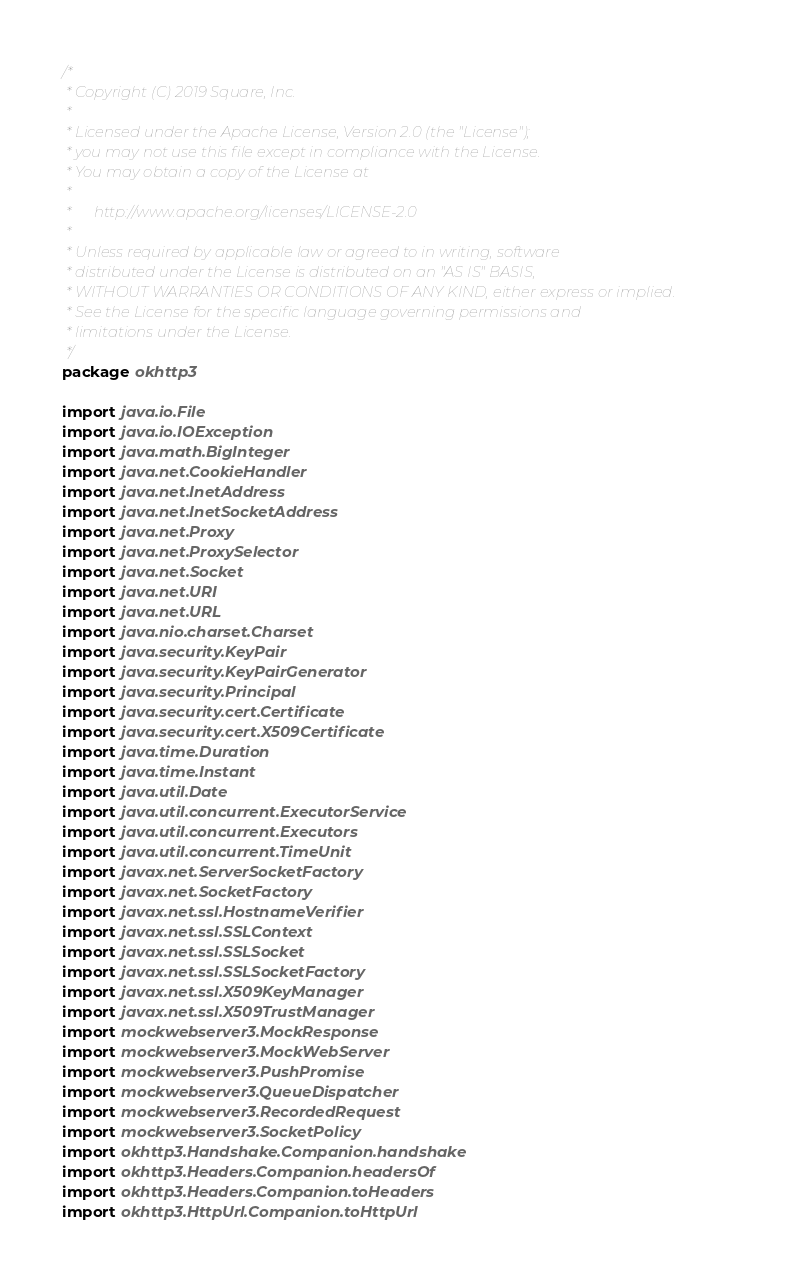<code> <loc_0><loc_0><loc_500><loc_500><_Kotlin_>/*
 * Copyright (C) 2019 Square, Inc.
 *
 * Licensed under the Apache License, Version 2.0 (the "License");
 * you may not use this file except in compliance with the License.
 * You may obtain a copy of the License at
 *
 *      http://www.apache.org/licenses/LICENSE-2.0
 *
 * Unless required by applicable law or agreed to in writing, software
 * distributed under the License is distributed on an "AS IS" BASIS,
 * WITHOUT WARRANTIES OR CONDITIONS OF ANY KIND, either express or implied.
 * See the License for the specific language governing permissions and
 * limitations under the License.
 */
package okhttp3

import java.io.File
import java.io.IOException
import java.math.BigInteger
import java.net.CookieHandler
import java.net.InetAddress
import java.net.InetSocketAddress
import java.net.Proxy
import java.net.ProxySelector
import java.net.Socket
import java.net.URI
import java.net.URL
import java.nio.charset.Charset
import java.security.KeyPair
import java.security.KeyPairGenerator
import java.security.Principal
import java.security.cert.Certificate
import java.security.cert.X509Certificate
import java.time.Duration
import java.time.Instant
import java.util.Date
import java.util.concurrent.ExecutorService
import java.util.concurrent.Executors
import java.util.concurrent.TimeUnit
import javax.net.ServerSocketFactory
import javax.net.SocketFactory
import javax.net.ssl.HostnameVerifier
import javax.net.ssl.SSLContext
import javax.net.ssl.SSLSocket
import javax.net.ssl.SSLSocketFactory
import javax.net.ssl.X509KeyManager
import javax.net.ssl.X509TrustManager
import mockwebserver3.MockResponse
import mockwebserver3.MockWebServer
import mockwebserver3.PushPromise
import mockwebserver3.QueueDispatcher
import mockwebserver3.RecordedRequest
import mockwebserver3.SocketPolicy
import okhttp3.Handshake.Companion.handshake
import okhttp3.Headers.Companion.headersOf
import okhttp3.Headers.Companion.toHeaders
import okhttp3.HttpUrl.Companion.toHttpUrl</code> 